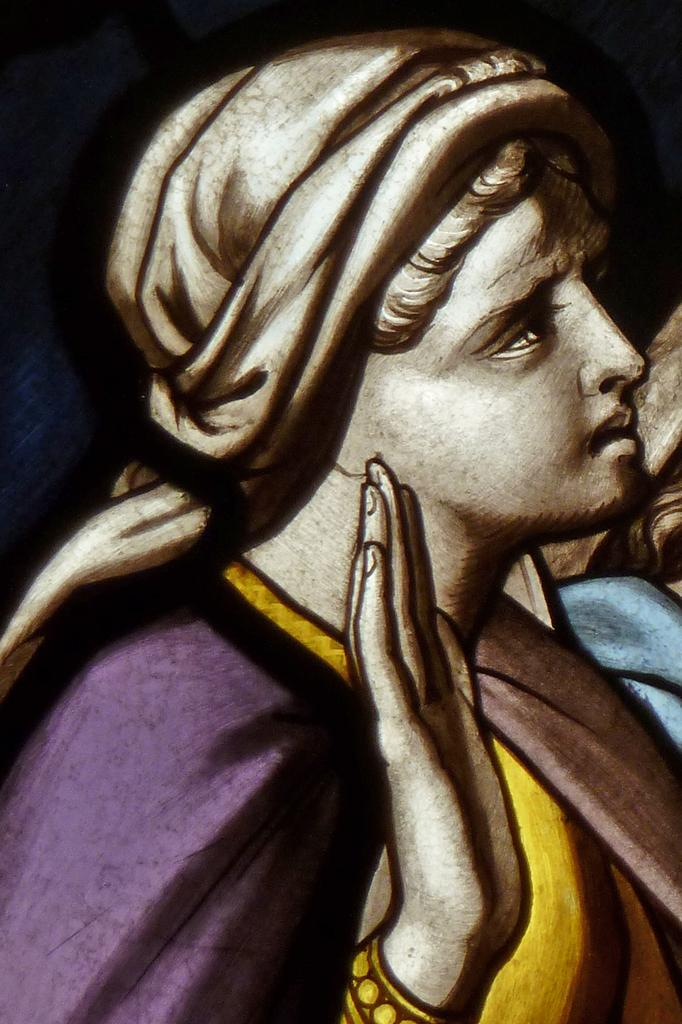What is the main subject of the image? There is a person depicted in the image. What colors are used in the person art? The person art is in purple, yellow, and brown colors. What color is the background of the image? The background of the image is black. What type of chalk is the person using to draw in the image? There is no chalk present in the image, and the person is not depicted drawing. 